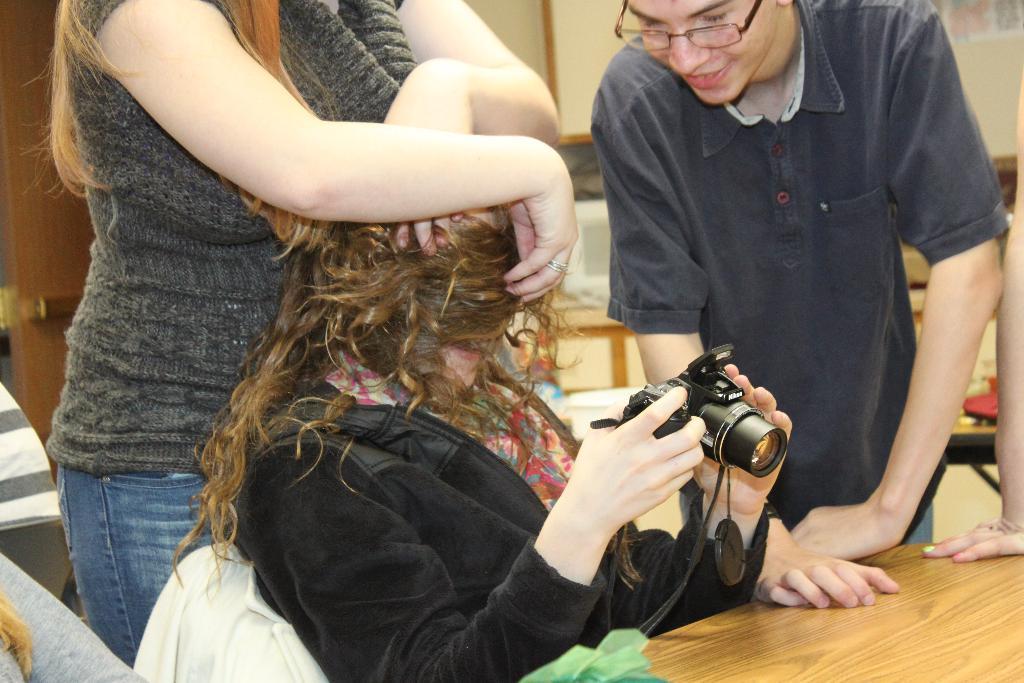How would you summarize this image in a sentence or two? In this picture there is a woman wearing a black jacket is holding a camera and sitting on the chair. There is a man wearing grey shirt i standing. There is other woman wearing a grey shirt is also standing. There is a table and a green cloth on the table. There is also another woman and a person. There is a white object on the table. 